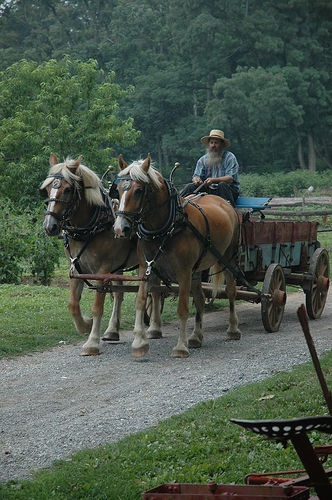Describe the objects in this image and their specific colors. I can see horse in darkgreen, black, and gray tones, horse in darkgreen, black, gray, and darkgray tones, and people in darkgreen, black, gray, darkgray, and blue tones in this image. 